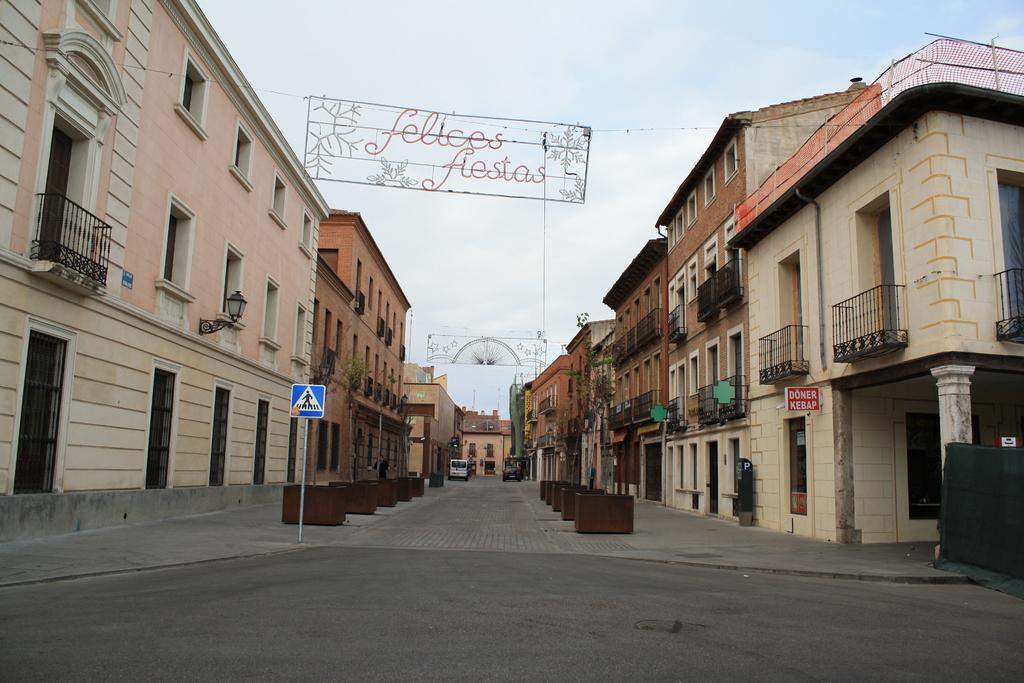What type of structures can be seen in the image? There are buildings in the image. What else can be seen on the buildings? There are sign boards on the buildings. What is happening on the road in the image? There are vehicles on the road in the image. What can be seen in the background of the image? The sky is visible in the background of the image. What type of linen can be seen hanging from the windows in the image? There is no linen visible in the image; it only features buildings, sign boards, vehicles, and the sky. 